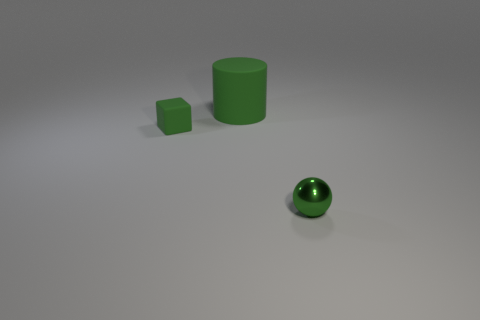Add 2 tiny spheres. How many objects exist? 5 Subtract all cubes. How many objects are left? 2 Add 2 large gray shiny things. How many large gray shiny things exist? 2 Subtract 1 green balls. How many objects are left? 2 Subtract all spheres. Subtract all rubber things. How many objects are left? 0 Add 1 tiny green objects. How many tiny green objects are left? 3 